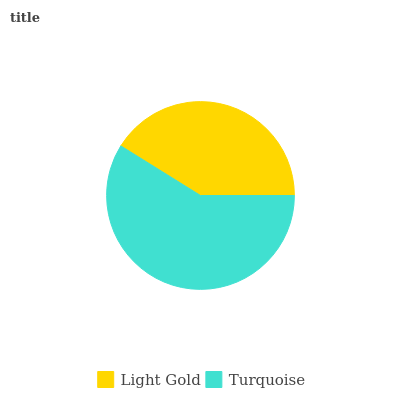Is Light Gold the minimum?
Answer yes or no. Yes. Is Turquoise the maximum?
Answer yes or no. Yes. Is Turquoise the minimum?
Answer yes or no. No. Is Turquoise greater than Light Gold?
Answer yes or no. Yes. Is Light Gold less than Turquoise?
Answer yes or no. Yes. Is Light Gold greater than Turquoise?
Answer yes or no. No. Is Turquoise less than Light Gold?
Answer yes or no. No. Is Turquoise the high median?
Answer yes or no. Yes. Is Light Gold the low median?
Answer yes or no. Yes. Is Light Gold the high median?
Answer yes or no. No. Is Turquoise the low median?
Answer yes or no. No. 